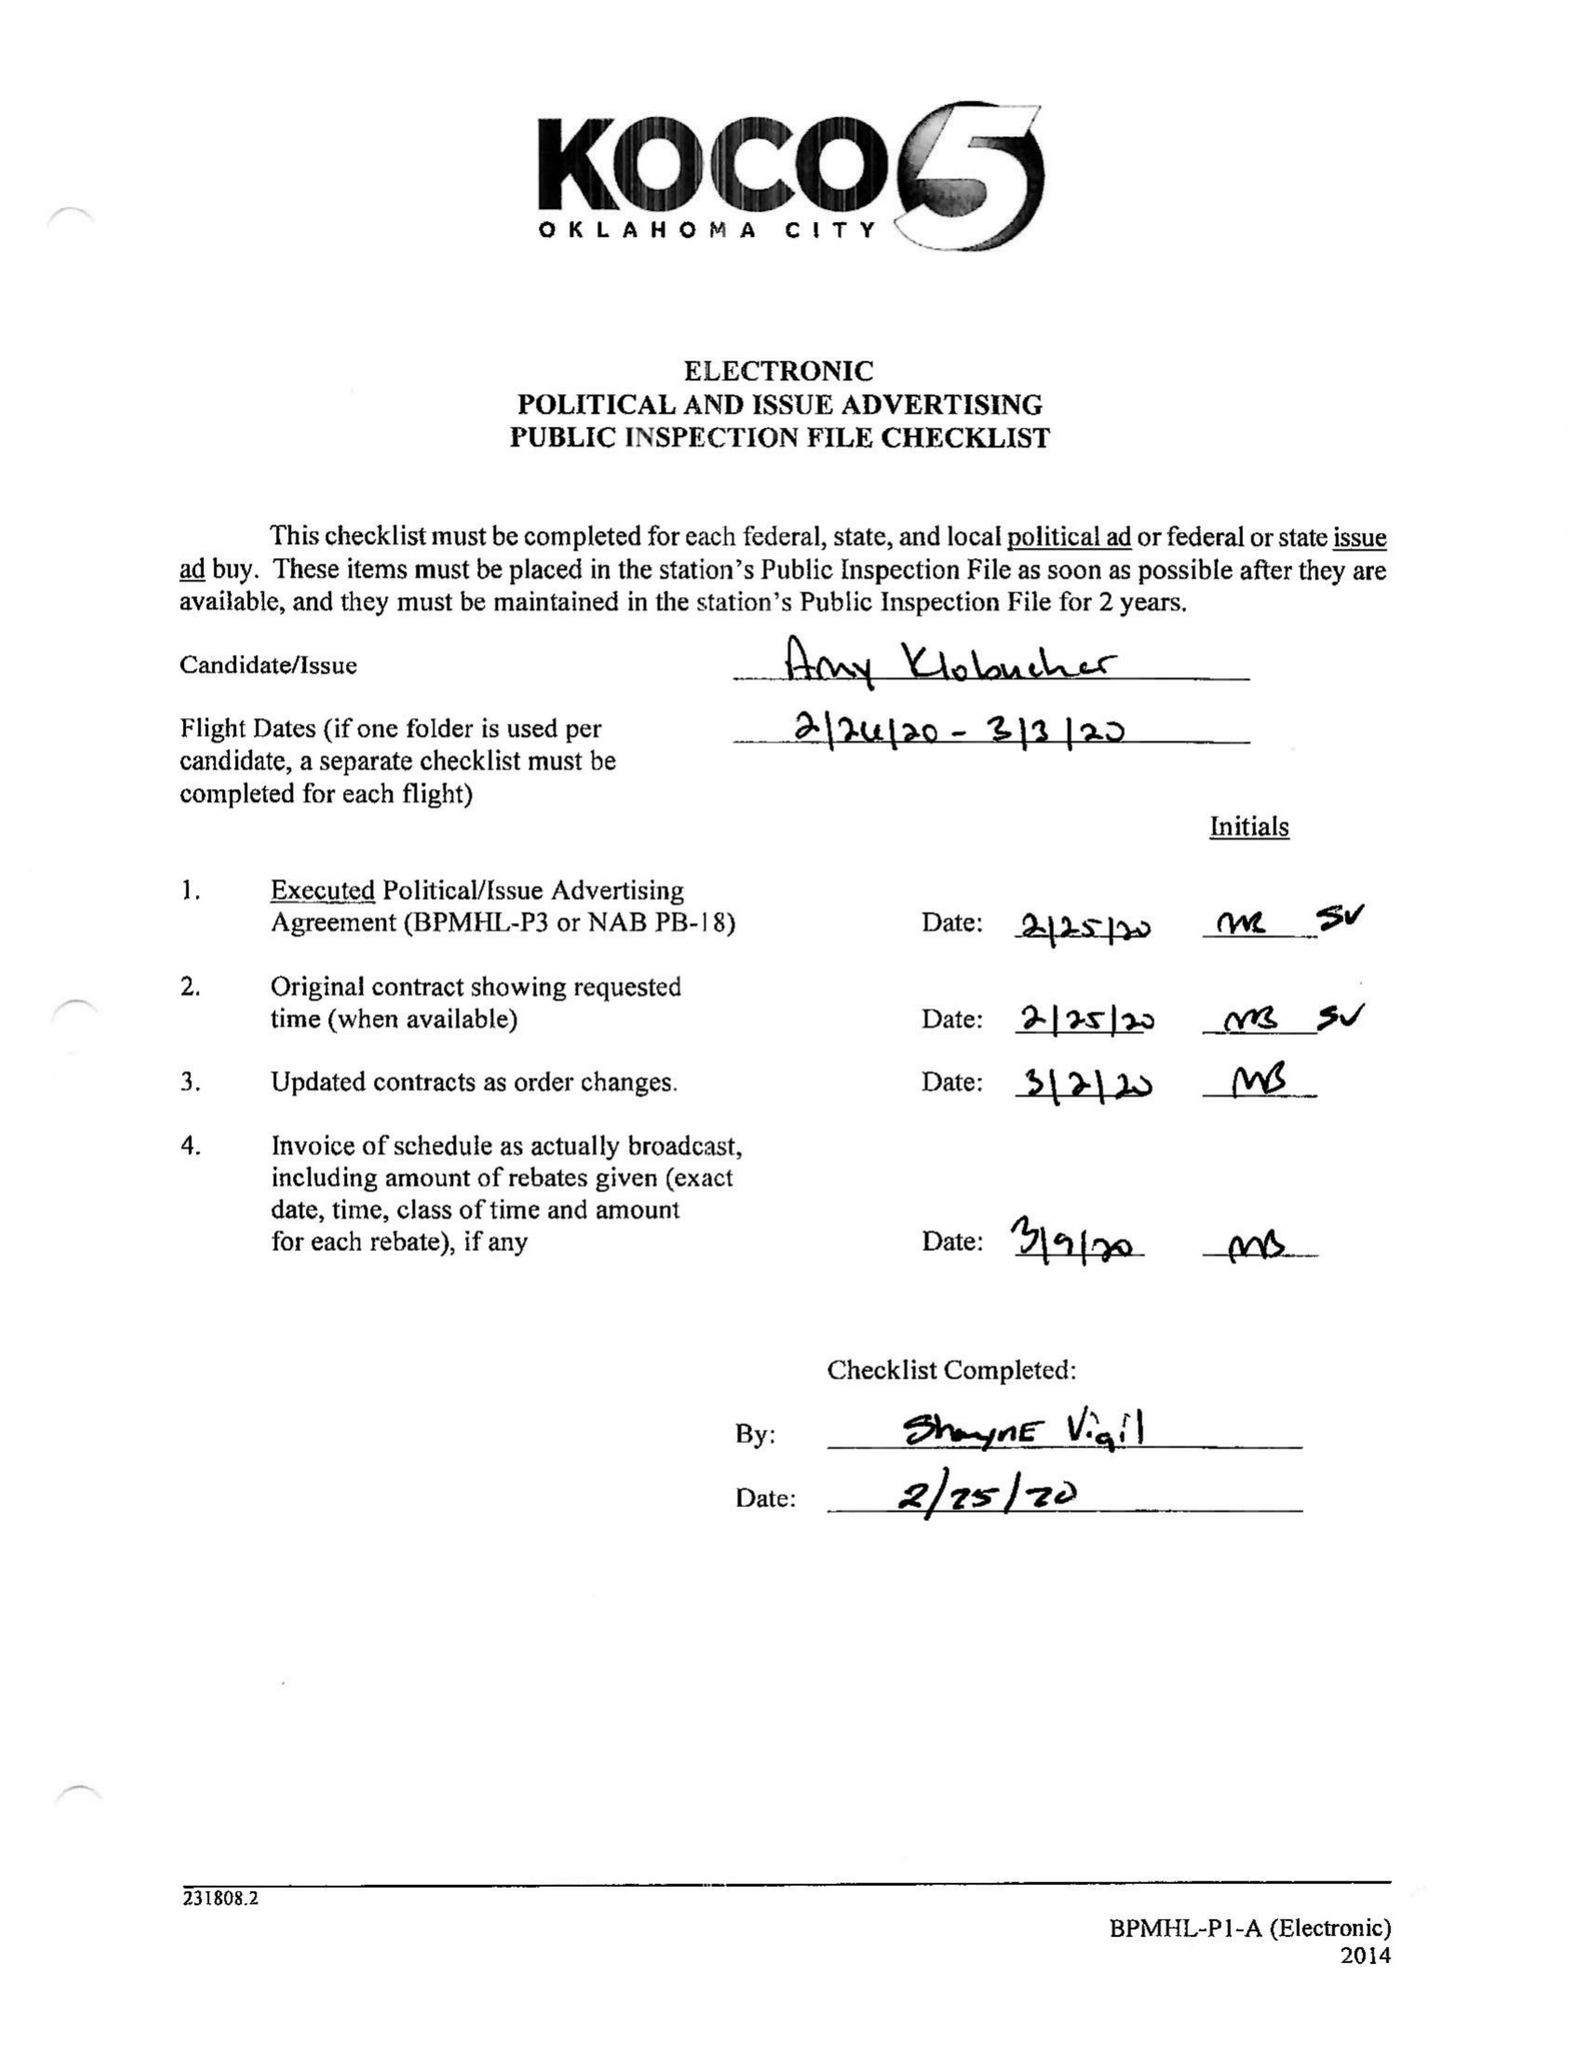What is the value for the flight_from?
Answer the question using a single word or phrase. 02/26/20 